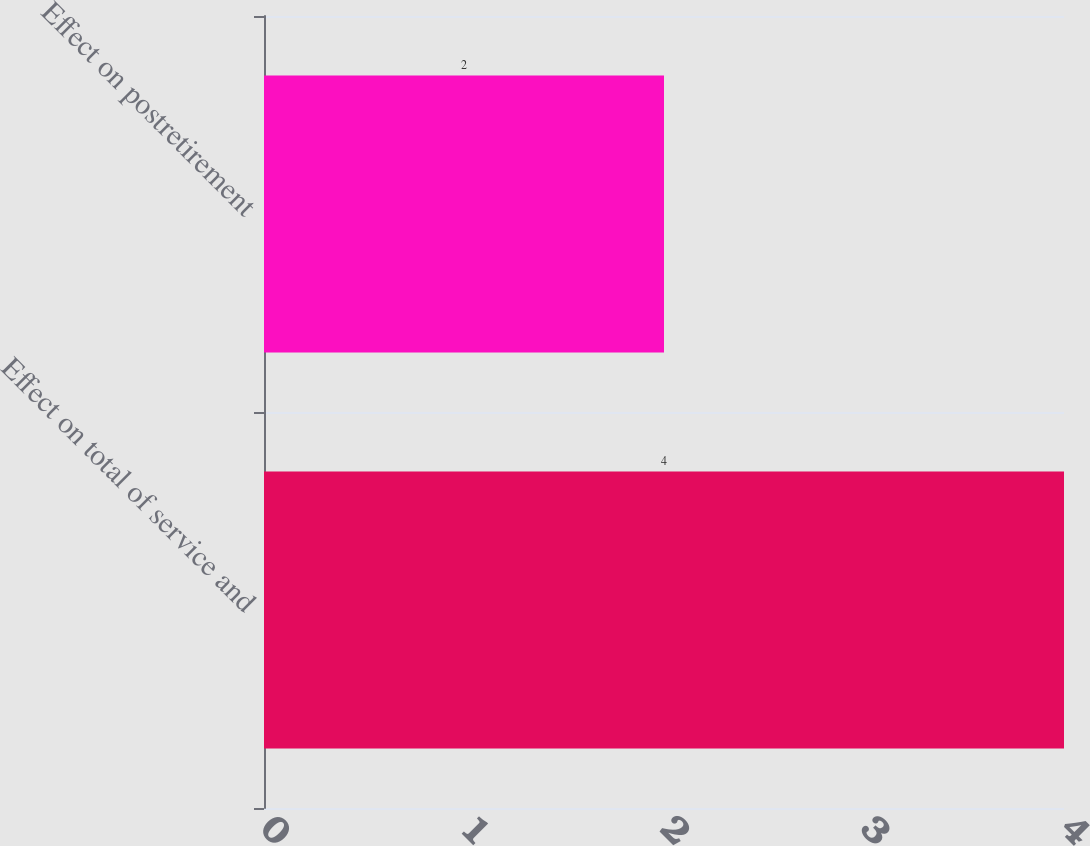Convert chart to OTSL. <chart><loc_0><loc_0><loc_500><loc_500><bar_chart><fcel>Effect on total of service and<fcel>Effect on postretirement<nl><fcel>4<fcel>2<nl></chart> 